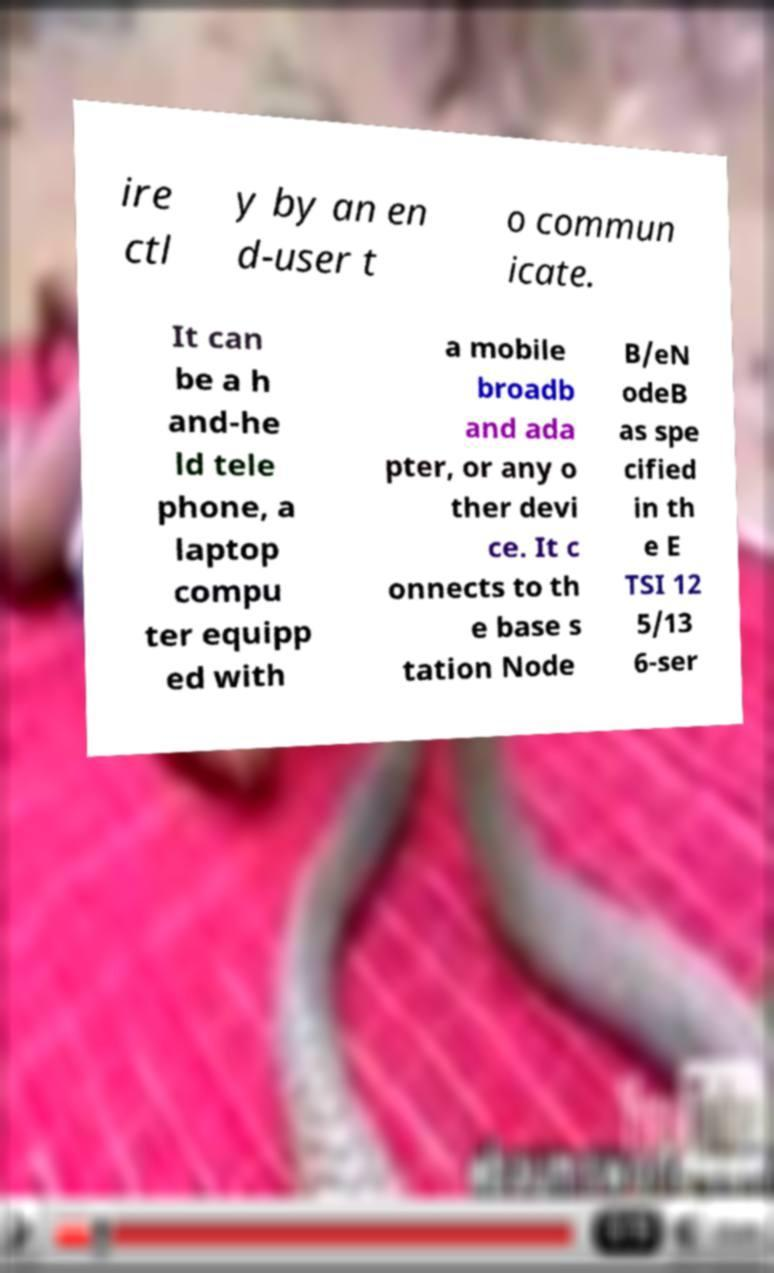Could you assist in decoding the text presented in this image and type it out clearly? ire ctl y by an en d-user t o commun icate. It can be a h and-he ld tele phone, a laptop compu ter equipp ed with a mobile broadb and ada pter, or any o ther devi ce. It c onnects to th e base s tation Node B/eN odeB as spe cified in th e E TSI 12 5/13 6-ser 